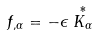Convert formula to latex. <formula><loc_0><loc_0><loc_500><loc_500>f _ { , \alpha } = - \epsilon \stackrel { * } { K _ { \alpha } }</formula> 